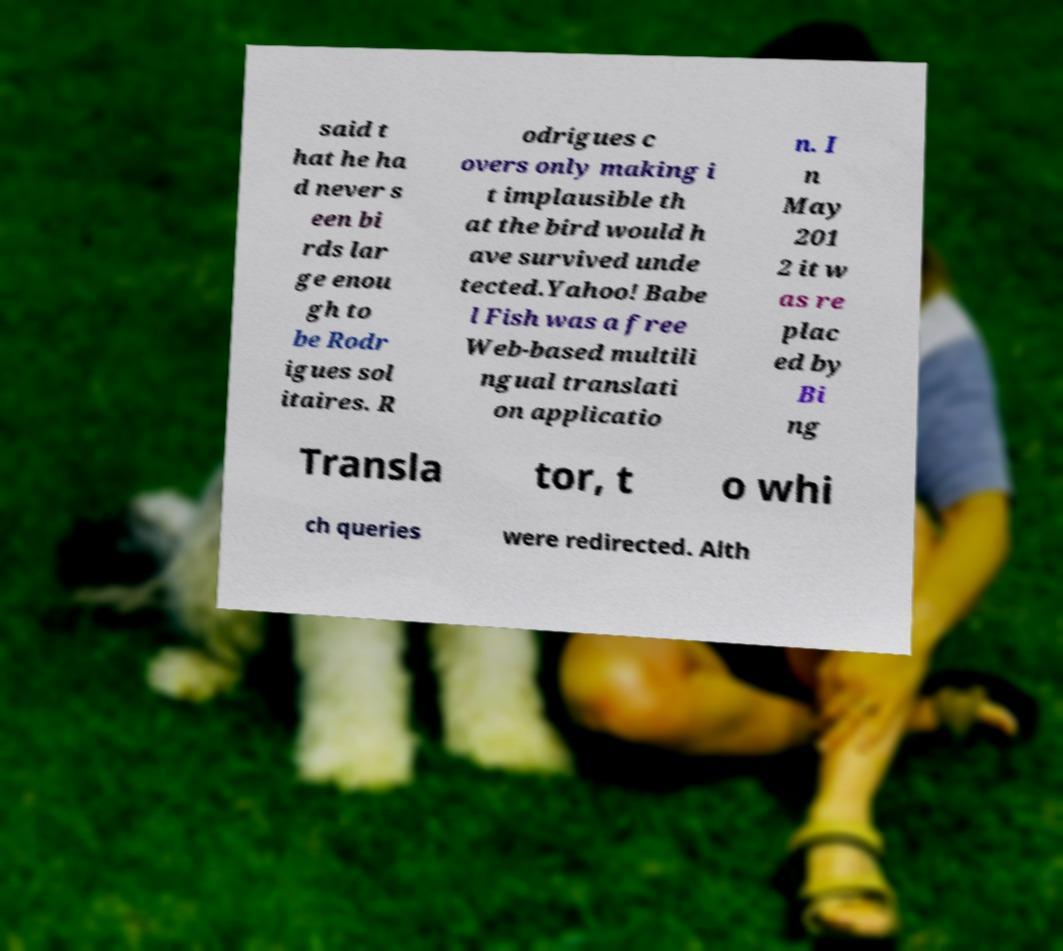Could you extract and type out the text from this image? said t hat he ha d never s een bi rds lar ge enou gh to be Rodr igues sol itaires. R odrigues c overs only making i t implausible th at the bird would h ave survived unde tected.Yahoo! Babe l Fish was a free Web-based multili ngual translati on applicatio n. I n May 201 2 it w as re plac ed by Bi ng Transla tor, t o whi ch queries were redirected. Alth 